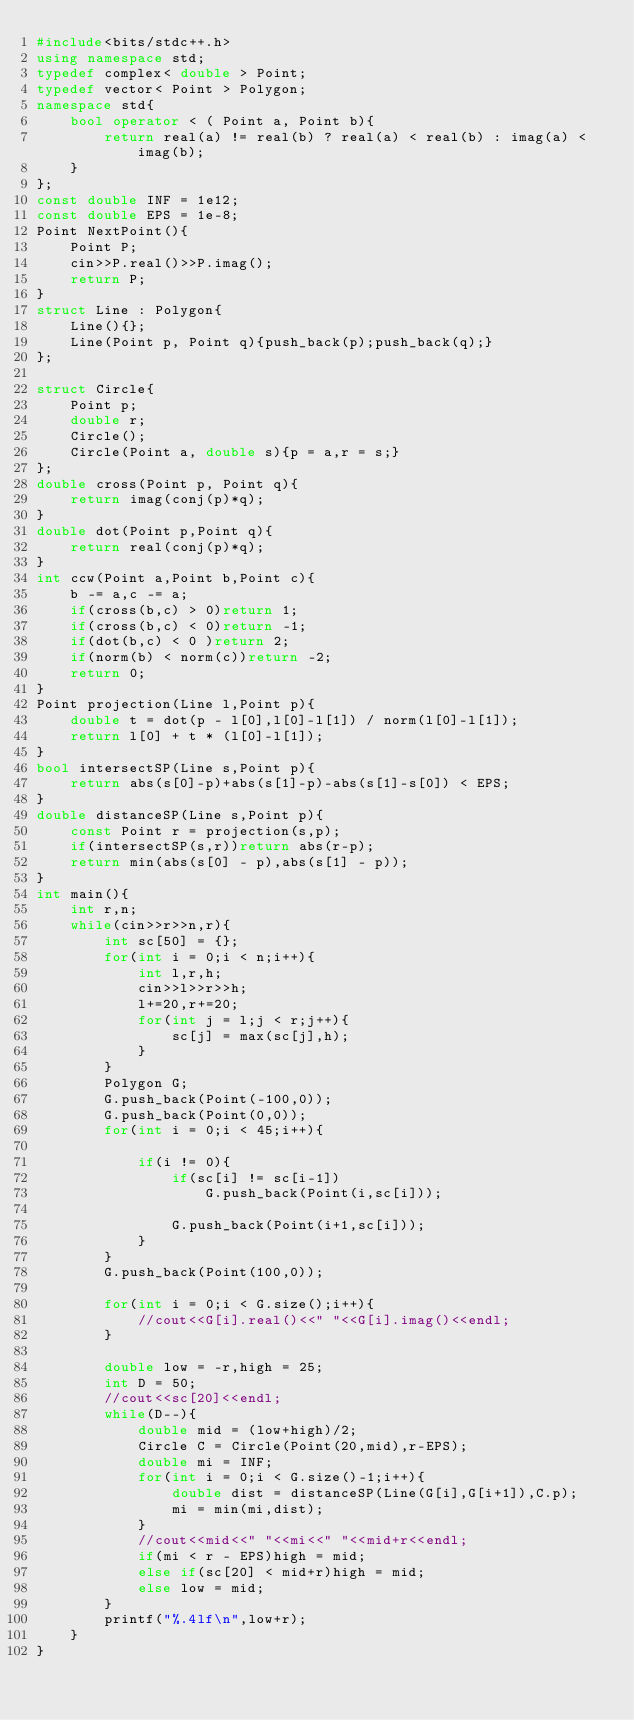Convert code to text. <code><loc_0><loc_0><loc_500><loc_500><_C++_>#include<bits/stdc++.h>
using namespace std;
typedef complex< double > Point;
typedef vector< Point > Polygon;
namespace std{
	bool operator < ( Point a, Point b){
		return real(a) != real(b) ? real(a) < real(b) : imag(a) < imag(b);
	}
};
const double INF = 1e12;
const double EPS = 1e-8;
Point NextPoint(){
	Point P;
	cin>>P.real()>>P.imag();
	return P;
}
struct Line : Polygon{
	Line(){};
	Line(Point p, Point q){push_back(p);push_back(q);}
};

struct Circle{
	Point p;
	double r;
	Circle();
	Circle(Point a, double s){p = a,r = s;}
};
double cross(Point p, Point q){
	return imag(conj(p)*q);
}
double dot(Point p,Point q){
	return real(conj(p)*q);
}
int ccw(Point a,Point b,Point c){
	b -= a,c -= a;
	if(cross(b,c) > 0)return 1;
	if(cross(b,c) < 0)return -1;
	if(dot(b,c) < 0 )return 2;
	if(norm(b) < norm(c))return -2;
	return 0;
}
Point projection(Line l,Point p){
	double t = dot(p - l[0],l[0]-l[1]) / norm(l[0]-l[1]);
	return l[0] + t * (l[0]-l[1]);
}
bool intersectSP(Line s,Point p){
	return abs(s[0]-p)+abs(s[1]-p)-abs(s[1]-s[0]) < EPS;
}
double distanceSP(Line s,Point p){
	const Point r = projection(s,p);
	if(intersectSP(s,r))return abs(r-p);
	return min(abs(s[0] - p),abs(s[1] - p));
}
int main(){
	int r,n;
	while(cin>>r>>n,r){
		int sc[50] = {};
		for(int i = 0;i < n;i++){
			int l,r,h;
			cin>>l>>r>>h;
			l+=20,r+=20;
			for(int j = l;j < r;j++){
				sc[j] = max(sc[j],h);
			}
		}
		Polygon G;
		G.push_back(Point(-100,0));
		G.push_back(Point(0,0));
		for(int i = 0;i < 45;i++){
			
			if(i != 0){
				if(sc[i] != sc[i-1])
					G.push_back(Point(i,sc[i]));
				
				G.push_back(Point(i+1,sc[i]));
			}
		}
		G.push_back(Point(100,0));

		for(int i = 0;i < G.size();i++){
			//cout<<G[i].real()<<" "<<G[i].imag()<<endl;
		}

		double low = -r,high = 25;
		int D = 50;
		//cout<<sc[20]<<endl;
		while(D--){
			double mid = (low+high)/2;
			Circle C = Circle(Point(20,mid),r-EPS);
			double mi = INF;
			for(int i = 0;i < G.size()-1;i++){
				double dist = distanceSP(Line(G[i],G[i+1]),C.p);
				mi = min(mi,dist);
			}
			//cout<<mid<<" "<<mi<<" "<<mid+r<<endl;
			if(mi < r - EPS)high = mid;
			else if(sc[20] < mid+r)high = mid;
			else low = mid;
		}
		printf("%.4lf\n",low+r);
	}
}</code> 